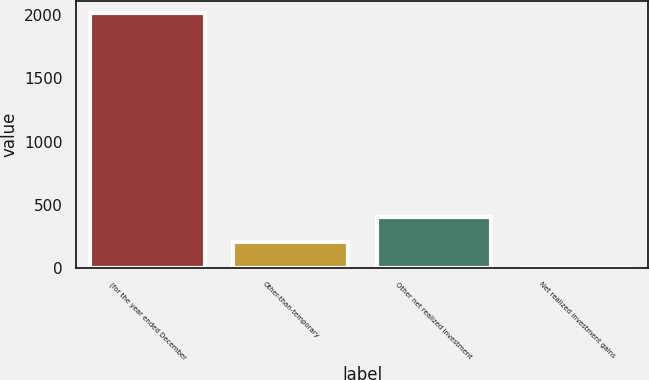Convert chart. <chart><loc_0><loc_0><loc_500><loc_500><bar_chart><fcel>(for the year ended December<fcel>Other-than-temporary<fcel>Other net realized investment<fcel>Net realized investment gains<nl><fcel>2015<fcel>204.2<fcel>405.4<fcel>3<nl></chart> 